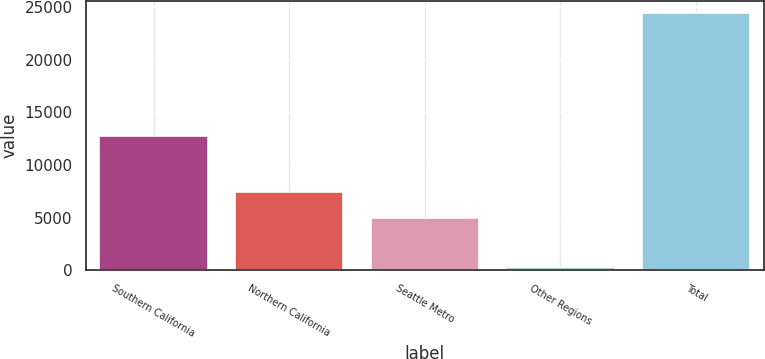Convert chart to OTSL. <chart><loc_0><loc_0><loc_500><loc_500><bar_chart><fcel>Southern California<fcel>Northern California<fcel>Seattle Metro<fcel>Other Regions<fcel>Total<nl><fcel>12725<fcel>7414.1<fcel>5005<fcel>302<fcel>24393<nl></chart> 